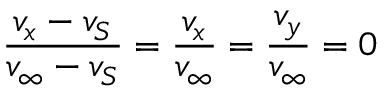<formula> <loc_0><loc_0><loc_500><loc_500>{ \frac { v _ { x } - v _ { S } } { v _ { \infty } - v _ { S } } } = { \frac { v _ { x } } { v _ { \infty } } } = { \frac { v _ { y } } { v _ { \infty } } } = 0</formula> 